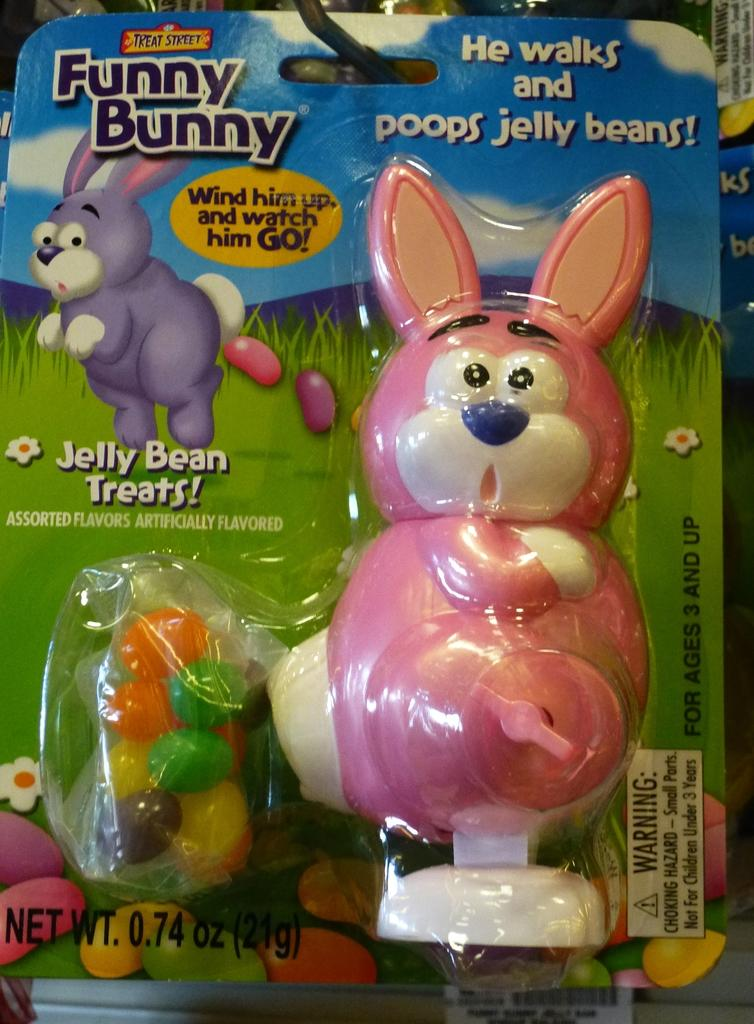What object is in the image that might be used for storing toys? There is a toy box in the image. What can be seen on the toy box? There is text visible on the toy box, and there is an image of an animal in the toy box. What type of surface is visible in the toy box? Grass is visible in the toy box. What else can be found in the toy box besides grass? There is a toy visible in the toy box, as well as small, colorful balls. How much payment is required to access the thoughts inside the toy box? There is no mention of payment or thoughts in the image; it features a toy box with various items inside. 